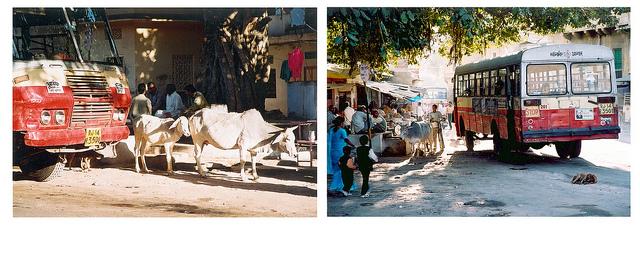Where are the cows?
Answer briefly. Street. Is there two different pictures in this images?
Give a very brief answer. Yes. How many wheels are on the bus?
Quick response, please. 6. 